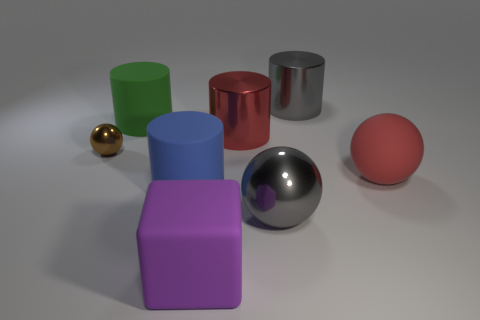Subtract all large red rubber spheres. How many spheres are left? 2 Add 2 gray metal balls. How many objects exist? 10 Subtract all red cylinders. How many cylinders are left? 3 Subtract all balls. How many objects are left? 5 Add 2 brown shiny balls. How many brown shiny balls are left? 3 Add 6 small blue rubber spheres. How many small blue rubber spheres exist? 6 Subtract 0 red cubes. How many objects are left? 8 Subtract all yellow blocks. Subtract all purple balls. How many blocks are left? 1 Subtract all large matte objects. Subtract all purple objects. How many objects are left? 3 